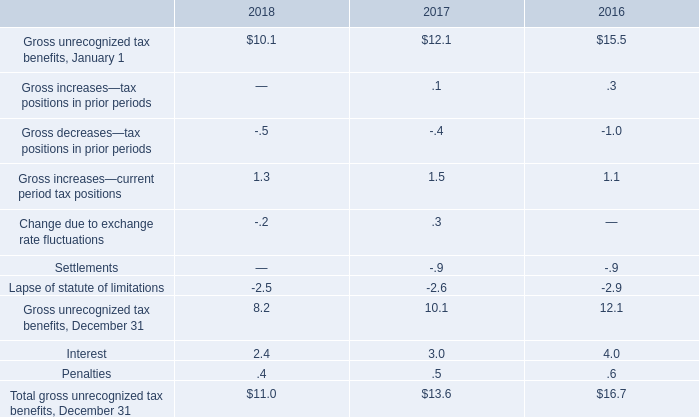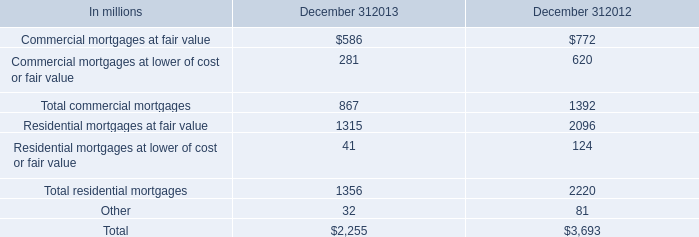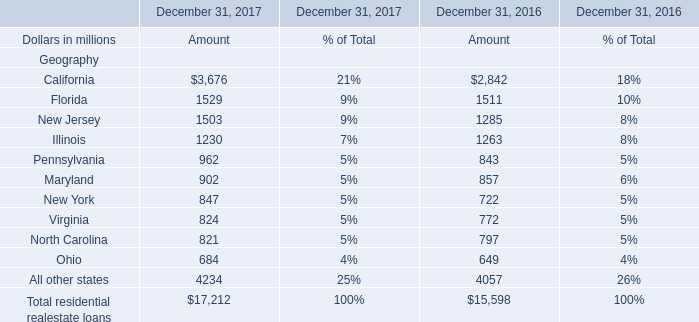What is the growing rate of New Jersey of Amount in Table 2 in the year with the most Gross increases—current period tax positions in Table 0? 
Computations: ((1503 - 1285) / 1285)
Answer: 0.16965. what's the total amount of California of December 31, 2017 Amount, Residential mortgages at fair value of December 312012, and New Jersey of December 31, 2017 Amount ? 
Computations: ((3676.0 + 2096.0) + 1503.0)
Answer: 7275.0. 